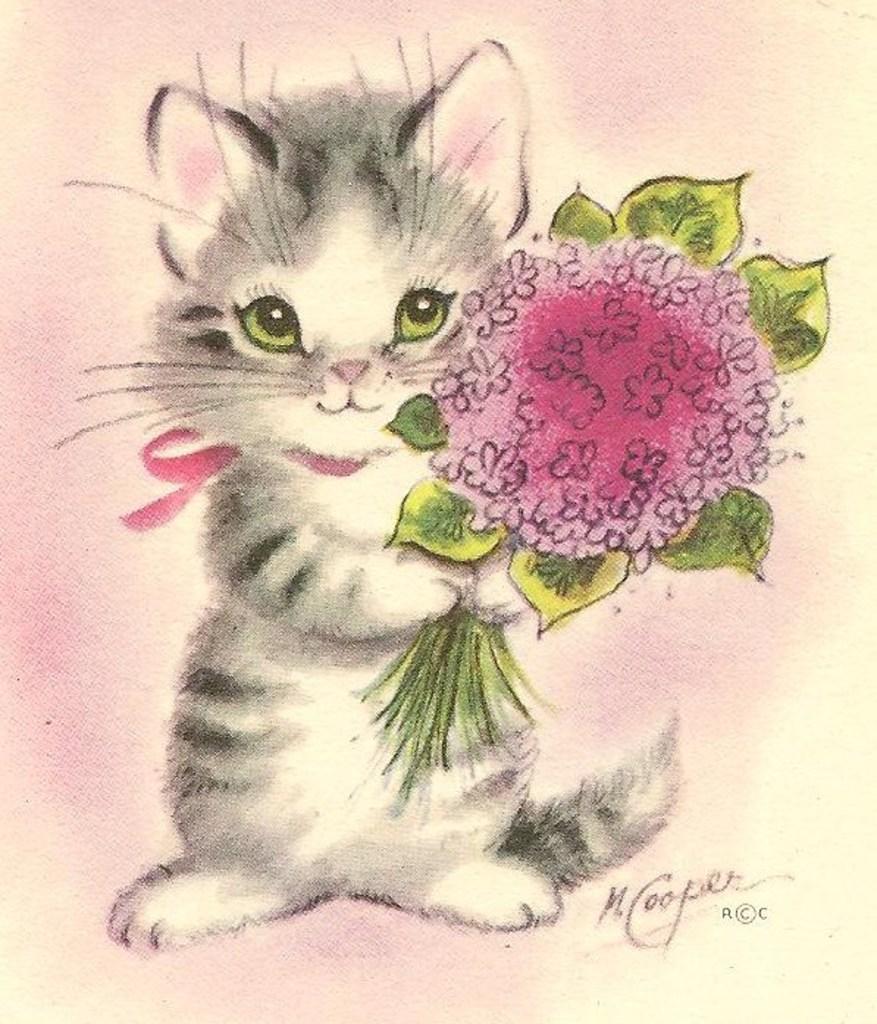In one or two sentences, can you explain what this image depicts? This image looks like a painting, in which I can see a cat is holding a bouquet in hand and I can see a text and a colorful background. 